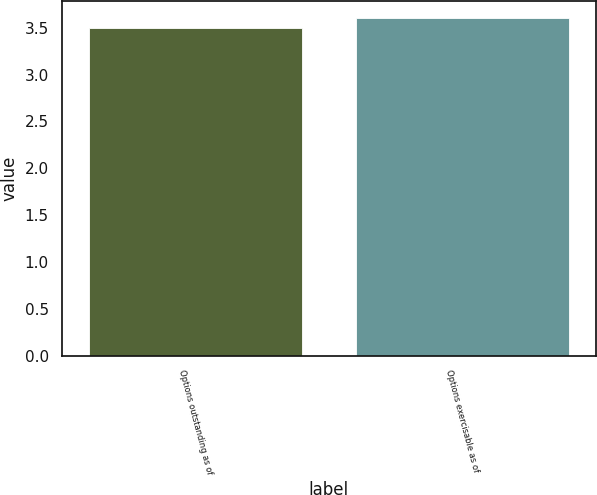<chart> <loc_0><loc_0><loc_500><loc_500><bar_chart><fcel>Options outstanding as of<fcel>Options exercisable as of<nl><fcel>3.5<fcel>3.6<nl></chart> 